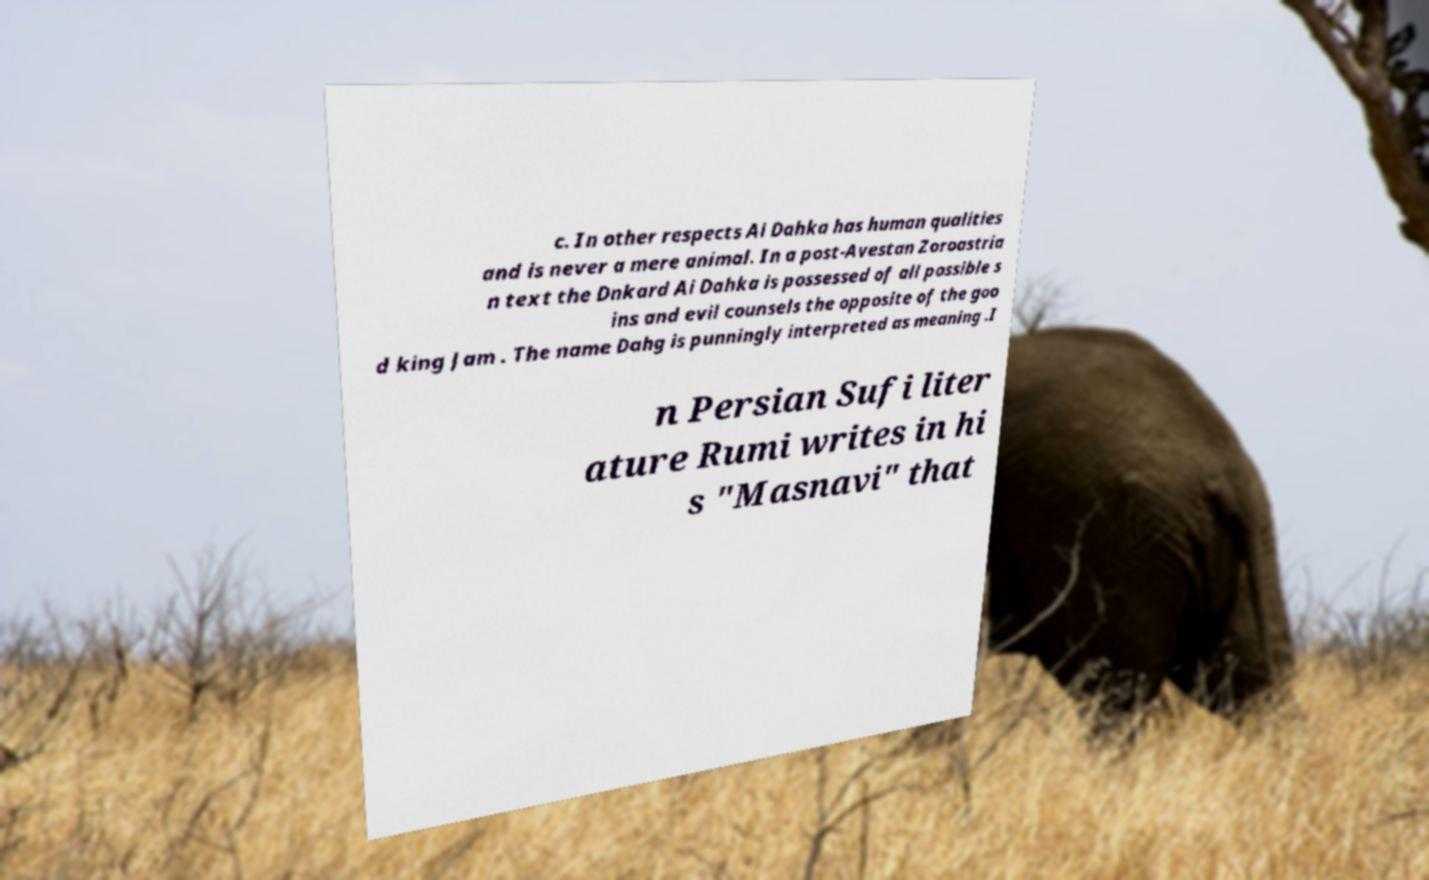Can you accurately transcribe the text from the provided image for me? c. In other respects Ai Dahka has human qualities and is never a mere animal. In a post-Avestan Zoroastria n text the Dnkard Ai Dahka is possessed of all possible s ins and evil counsels the opposite of the goo d king Jam . The name Dahg is punningly interpreted as meaning .I n Persian Sufi liter ature Rumi writes in hi s "Masnavi" that 